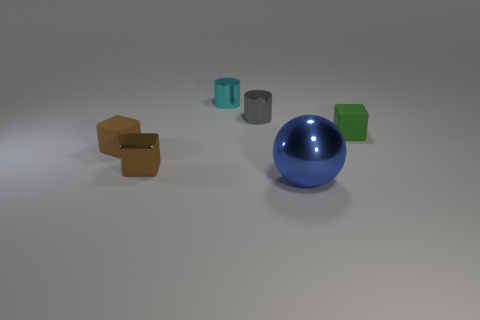There is another tiny object that is the same shape as the gray object; what is its material?
Your response must be concise. Metal. Is the green thing made of the same material as the big blue ball?
Your answer should be very brief. No. Are there any other things that have the same material as the green thing?
Your answer should be compact. Yes. Are there more brown metallic objects left of the brown shiny block than tiny cylinders?
Give a very brief answer. No. Does the sphere have the same color as the tiny shiny cube?
Provide a succinct answer. No. How many other large objects are the same shape as the cyan object?
Offer a terse response. 0. There is a brown object that is made of the same material as the cyan cylinder; what size is it?
Offer a very short reply. Small. There is a cube that is left of the small green rubber block and behind the tiny metallic block; what is its color?
Offer a very short reply. Brown. What number of brown rubber things have the same size as the gray shiny cylinder?
Give a very brief answer. 1. There is a rubber block that is the same color as the tiny shiny cube; what is its size?
Your response must be concise. Small. 